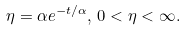<formula> <loc_0><loc_0><loc_500><loc_500>\eta = \alpha e ^ { - t / \alpha } , \, 0 < \eta < \infty .</formula> 